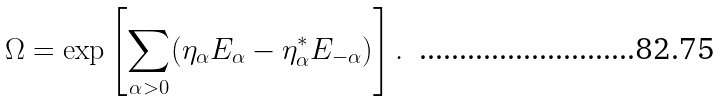<formula> <loc_0><loc_0><loc_500><loc_500>\Omega = \exp \left [ \sum _ { \alpha > 0 } ( \eta _ { \alpha } E _ { \alpha } - \eta _ { \alpha } ^ { \ast } E _ { - \alpha } ) \right ] .</formula> 